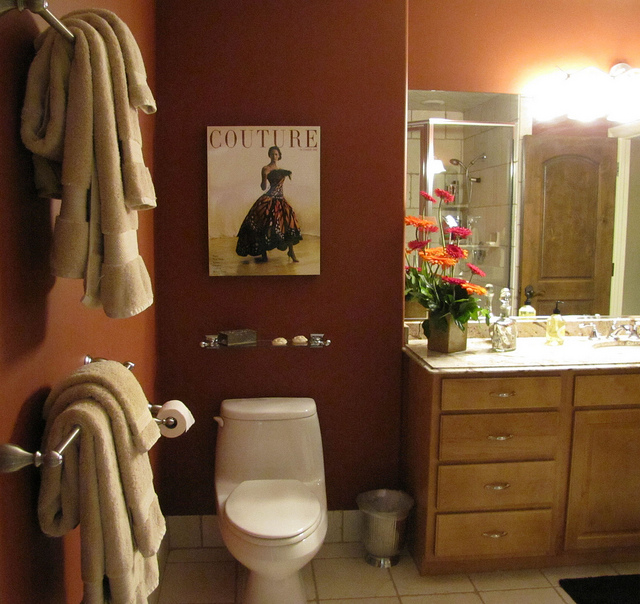Please extract the text content from this image. COUTURE 